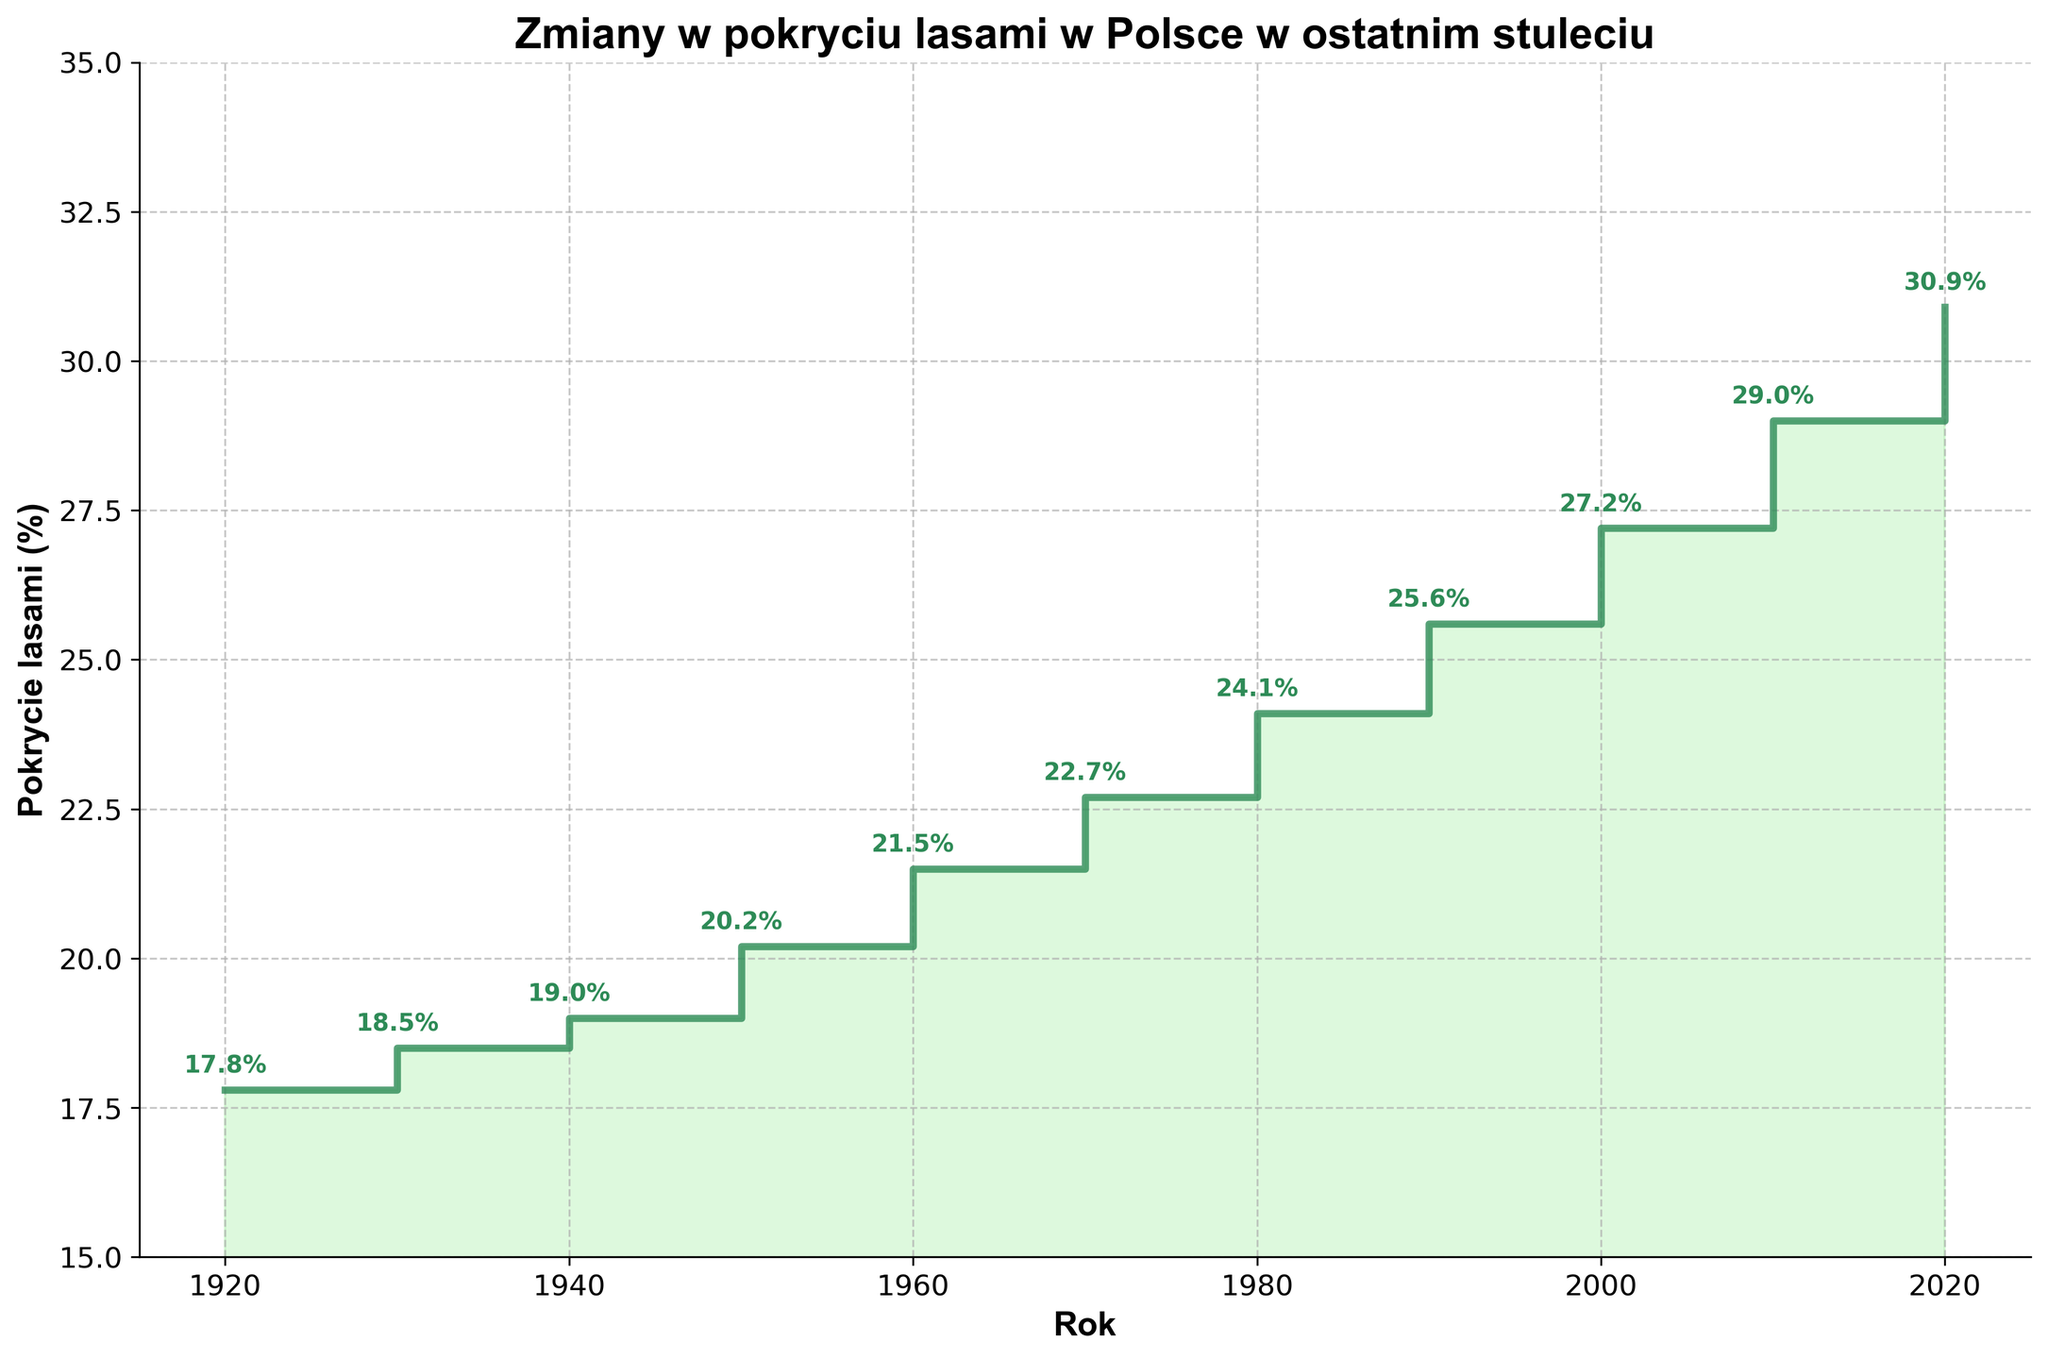What is the title of the figure? The title is prominently displayed at the top of the figure. It reads "Zmiany w pokryciu lasami w Polsce w ostatnim stuleciu," which translates to "Forest Cover Changes in Poland Over the Last Century."
Answer: Zmiany w pokryciu lasami w Polsce w ostatnim stuleciu What are the units used on the y-axis? The y-axis label reads "Pokrycie lasami (%)," which indicates that the units are in percentages.
Answer: Percentages What is the forest cover percentage in 1940? By locating the point directly above the year 1940 on the x-axis and reading the annotated value, we find that the forest cover percentage is 19.0%.
Answer: 19.0% How much did the forest cover increase from 1920 to 2020? The forest cover percentage in 1920 is 17.8%, and it is 30.9% in 2020. Subtracting the former from the latter gives 30.9 - 17.8 = 13.1.
Answer: 13.1% During which decade did the forest cover percentage experience the greatest increase? By examining the differences in forest cover for each decade, we observe the values: 0.7 (1920-1930), 0.5 (1930-1940), 1.2 (1940-1950), 1.3 (1950-1960), 1.2 (1960-1970), 1.4 (1970-1980), 1.5 (1980-1990), 1.6 (1990-2000), 1.8 (2000-2010), and 1.9 (2010-2020). The largest increase is 1.9% in the 2010-2020 decade.
Answer: 2010-2020 Compare the slope of the segments from 1950 to 1970 and 2000 to 2020. Which period experienced a higher rate of increase in forest cover? Between 1950 (20.2%) and 1970 (22.7%), the change is 22.7 - 20.2 = 2.5 over 20 years, or 2.5/20 = 0.125% per year. Between 2000 (27.2%) and 2020 (30.9%), the change is 30.9 - 27.2 = 3.7 over 20 years, or 3.7/20 = 0.185% per year. The 2000-2020 period had a higher rate of increase.
Answer: 2000-2020 Which year had the lowest forest cover percentage, and what was it? The lowest annotated value on the figure is above the year 1920, which is 17.8%.
Answer: 1920, 17.8% What is the average forest cover percentage across the entire period from 1920 to 2020? Summing up the percentages gives 17.8 + 18.5 + 19.0 + 20.2 + 21.5 + 22.7 + 24.1 + 25.6 + 27.2 + 29.0 + 30.9 = 256.5. There are 11 data points, so the average is 256.5 / 11 ≈ 23.32%.
Answer: 23.32% Identify two consecutive decades where the forest cover percentage increased by the same amount. By examining the increases: 1920-1930 (0.7), 1930-1940 (0.5), 1940-1950 (1.2), 1950-1960 (1.3), 1960-1970 (1.2), 1970-1980 (1.4), 1980-1990 (1.5), 1990-2000 (1.6), 2000-2010 (1.8), 2010-2020 (1.9). The periods 1940-1950 and 1960-1970 both have an increase of 1.2%.
Answer: 1940-1950 and 1960-1970 